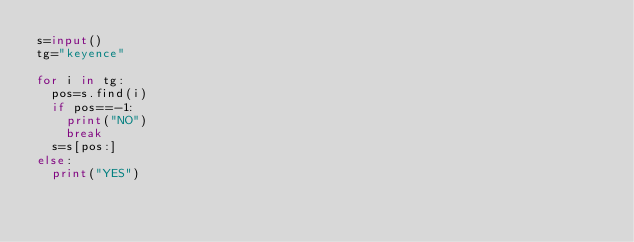Convert code to text. <code><loc_0><loc_0><loc_500><loc_500><_Python_>s=input()
tg="keyence"

for i in tg:
  pos=s.find(i)
  if pos==-1:
    print("NO")
    break
  s=s[pos:]
else:
  print("YES")</code> 